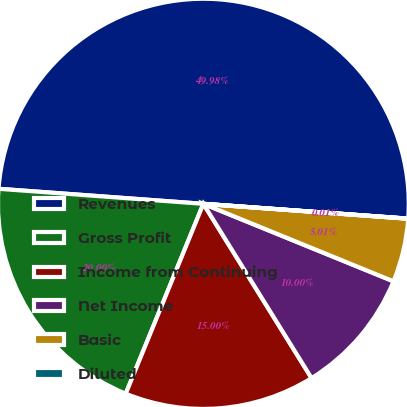<chart> <loc_0><loc_0><loc_500><loc_500><pie_chart><fcel>Revenues<fcel>Gross Profit<fcel>Income from Continuing<fcel>Net Income<fcel>Basic<fcel>Diluted<nl><fcel>49.98%<fcel>20.0%<fcel>15.0%<fcel>10.0%<fcel>5.01%<fcel>0.01%<nl></chart> 